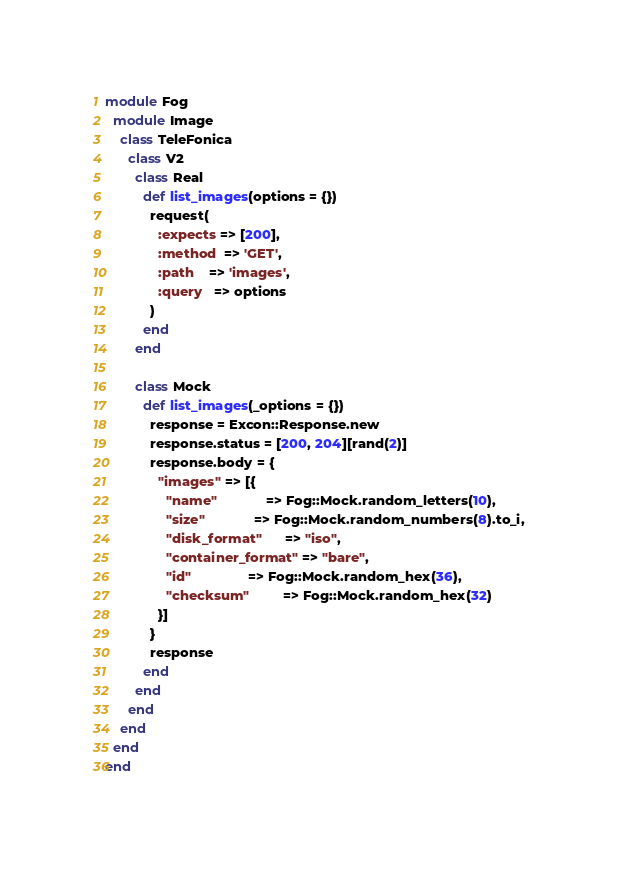Convert code to text. <code><loc_0><loc_0><loc_500><loc_500><_Ruby_>module Fog
  module Image
    class TeleFonica
      class V2
        class Real
          def list_images(options = {})
            request(
              :expects => [200],
              :method  => 'GET',
              :path    => 'images',
              :query   => options
            )
          end
        end

        class Mock
          def list_images(_options = {})
            response = Excon::Response.new
            response.status = [200, 204][rand(2)]
            response.body = {
              "images" => [{
                "name"             => Fog::Mock.random_letters(10),
                "size"             => Fog::Mock.random_numbers(8).to_i,
                "disk_format"      => "iso",
                "container_format" => "bare",
                "id"               => Fog::Mock.random_hex(36),
                "checksum"         => Fog::Mock.random_hex(32)
              }]
            }
            response
          end
        end
      end
    end
  end
end
</code> 